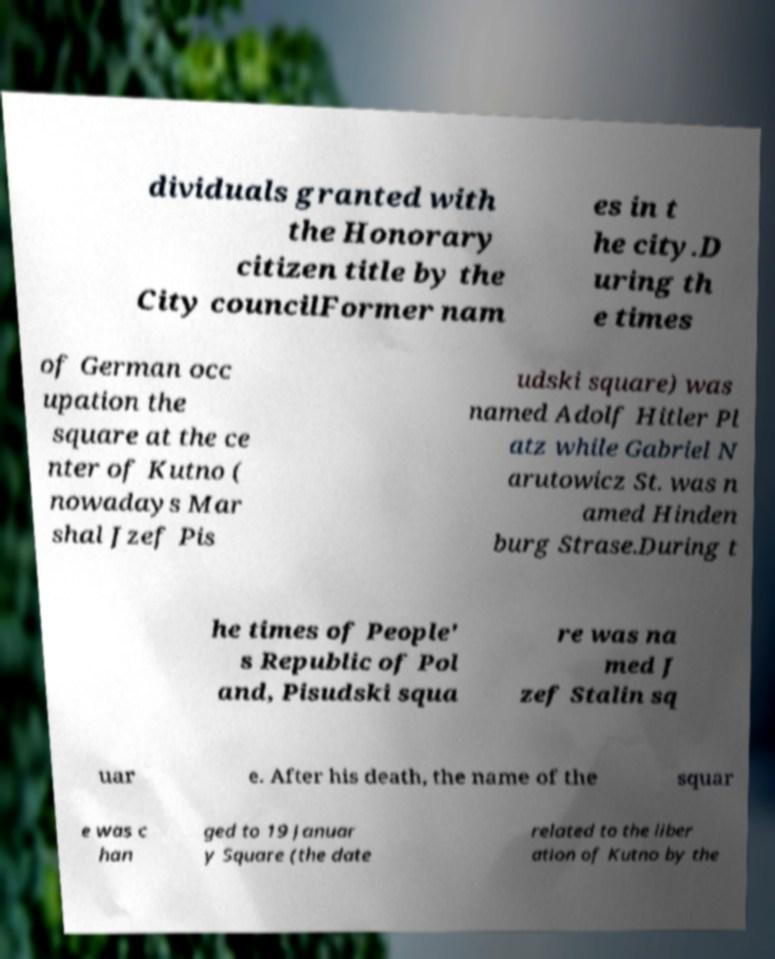For documentation purposes, I need the text within this image transcribed. Could you provide that? dividuals granted with the Honorary citizen title by the City councilFormer nam es in t he city.D uring th e times of German occ upation the square at the ce nter of Kutno ( nowadays Mar shal Jzef Pis udski square) was named Adolf Hitler Pl atz while Gabriel N arutowicz St. was n amed Hinden burg Strase.During t he times of People' s Republic of Pol and, Pisudski squa re was na med J zef Stalin sq uar e. After his death, the name of the squar e was c han ged to 19 Januar y Square (the date related to the liber ation of Kutno by the 